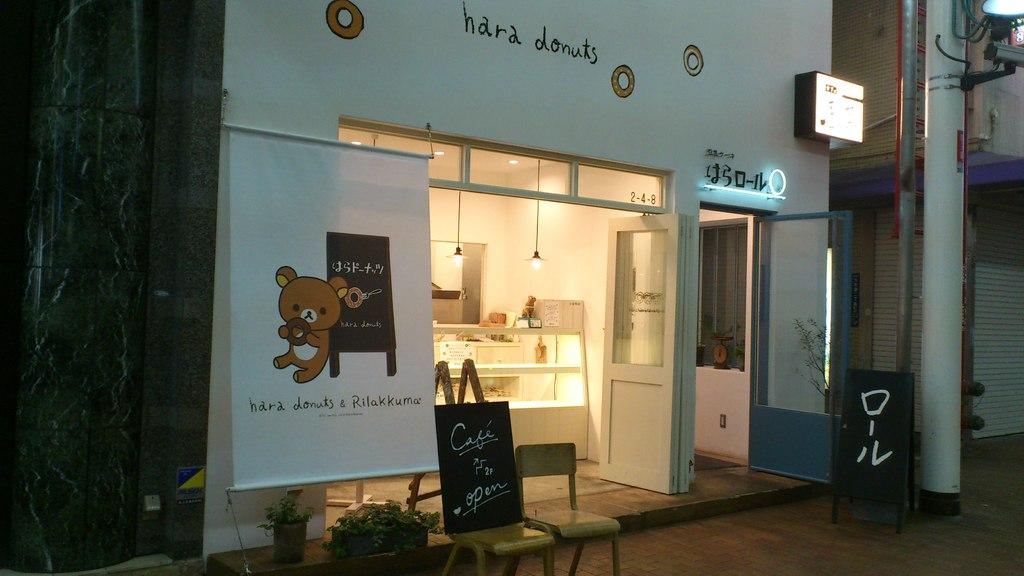What type of establishment is shown in the image? The image depicts a store. What objects are near the store? There are boards near the store. How can people enter or exit the store? There is a door in the image. What helps to illuminate the store and its surroundings? There are lights visible in the image. What type of outdoor lighting is present in the image? There is a street light with a pole in the image. How many potatoes are stacked on the chair in the image? There is no chair or potatoes present in the image. What type of jail can be seen in the image? There is no jail present in the image; it depicts a store with a street light and boards. 